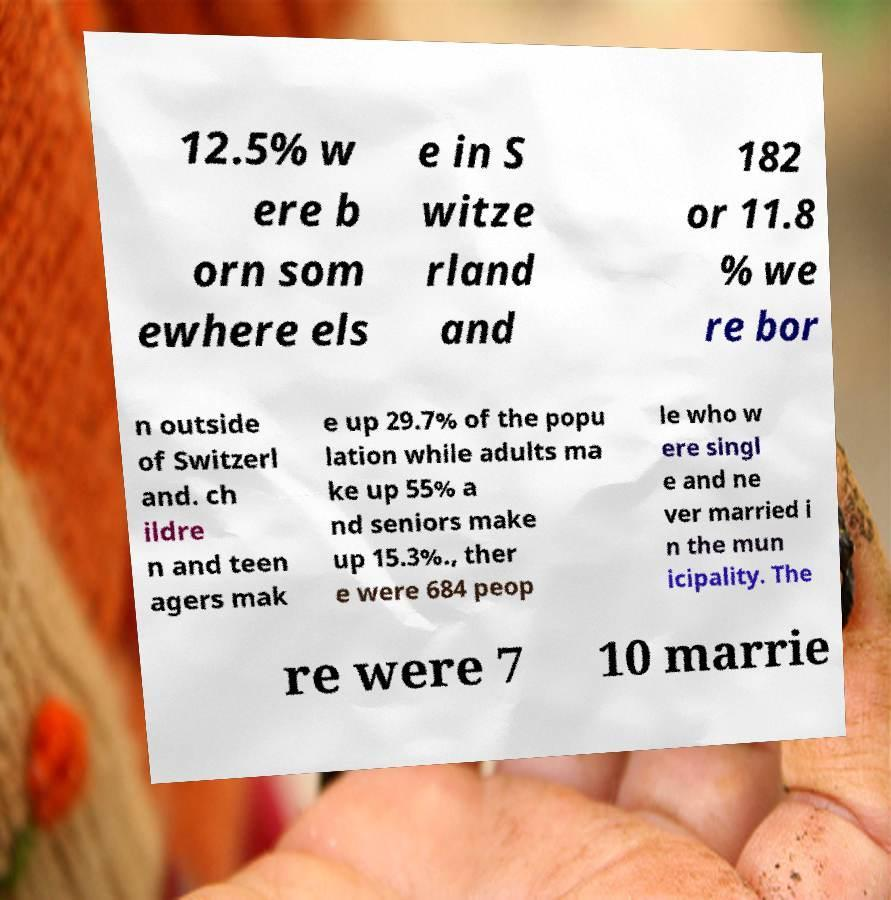For documentation purposes, I need the text within this image transcribed. Could you provide that? 12.5% w ere b orn som ewhere els e in S witze rland and 182 or 11.8 % we re bor n outside of Switzerl and. ch ildre n and teen agers mak e up 29.7% of the popu lation while adults ma ke up 55% a nd seniors make up 15.3%., ther e were 684 peop le who w ere singl e and ne ver married i n the mun icipality. The re were 7 10 marrie 